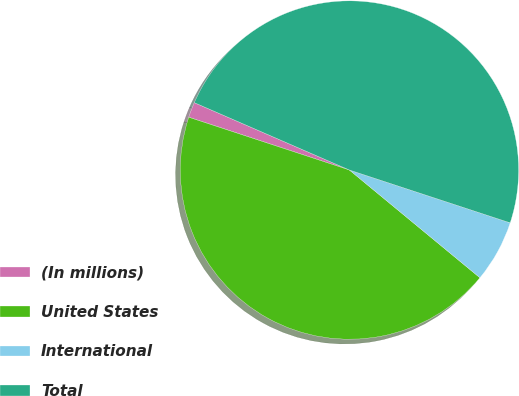Convert chart. <chart><loc_0><loc_0><loc_500><loc_500><pie_chart><fcel>(In millions)<fcel>United States<fcel>International<fcel>Total<nl><fcel>1.47%<fcel>44.07%<fcel>5.93%<fcel>48.53%<nl></chart> 